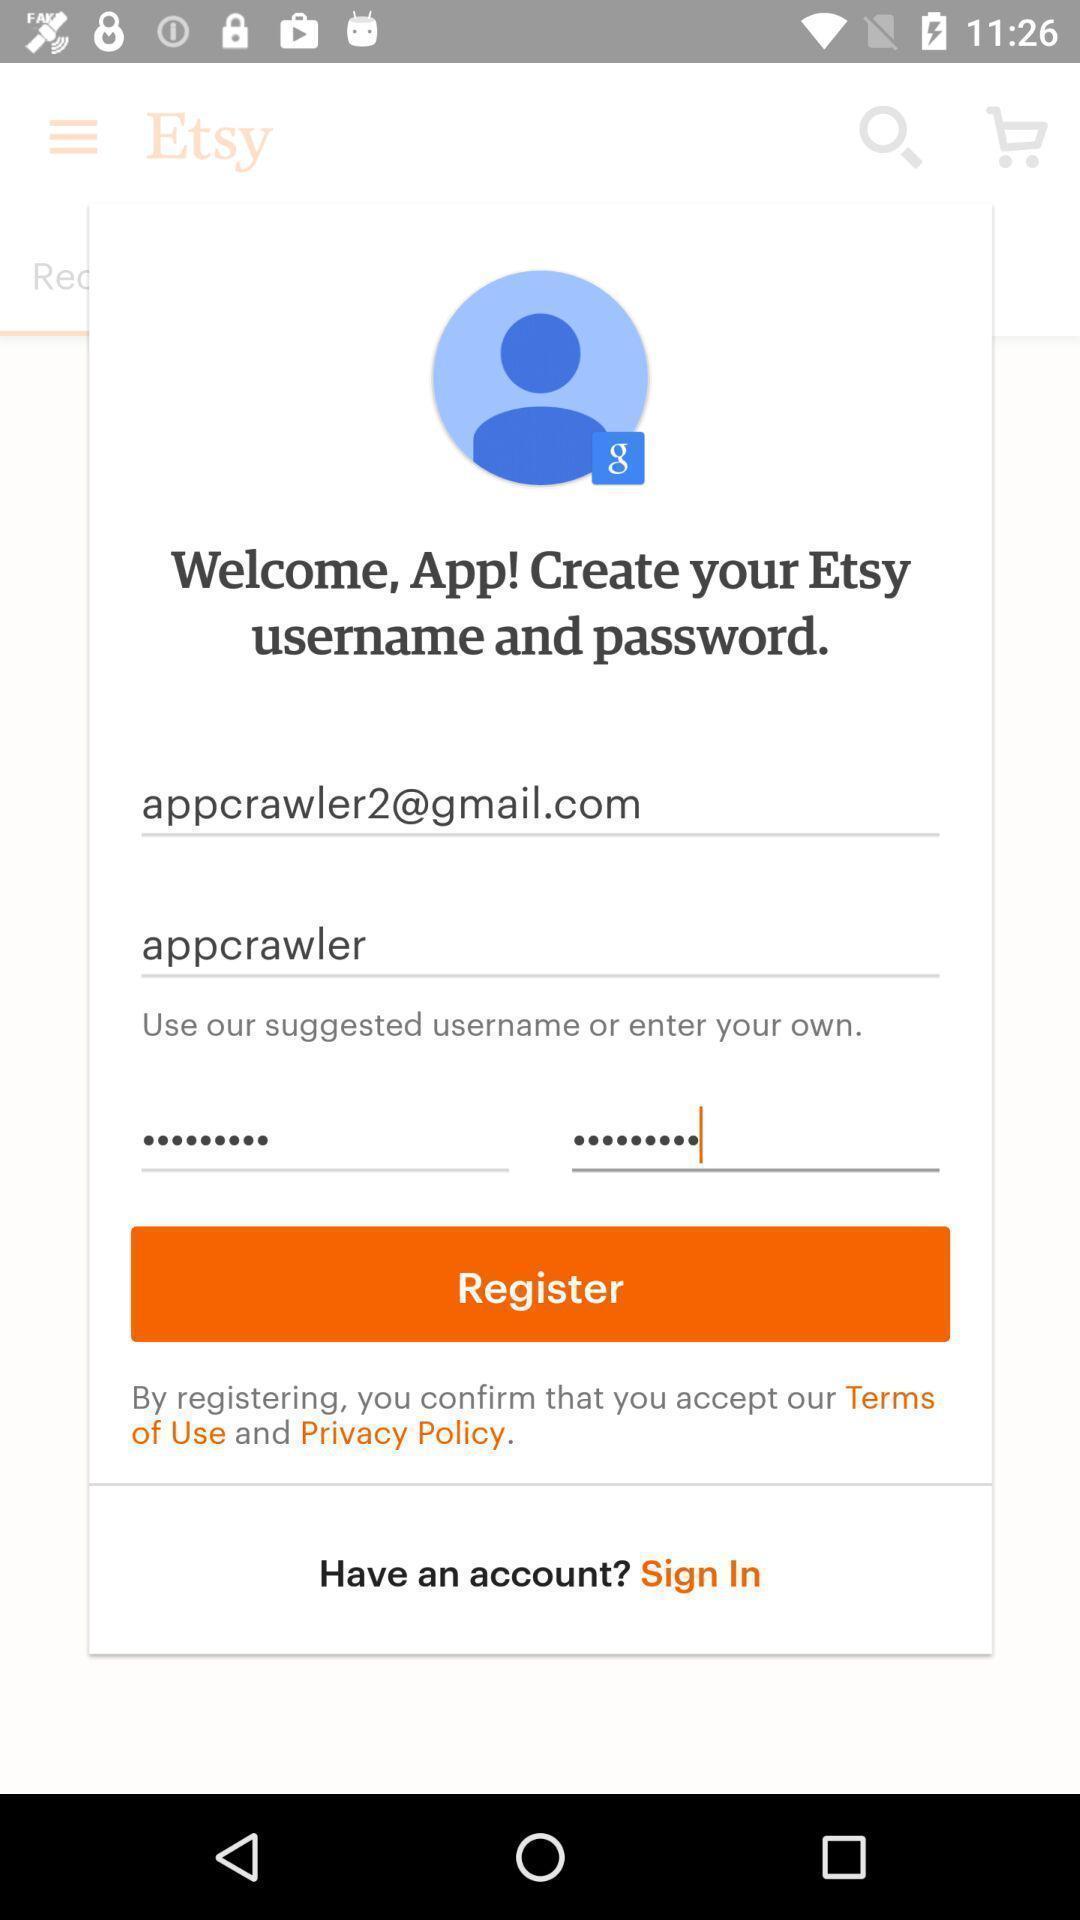Provide a description of this screenshot. Sign in page of shopping application. 